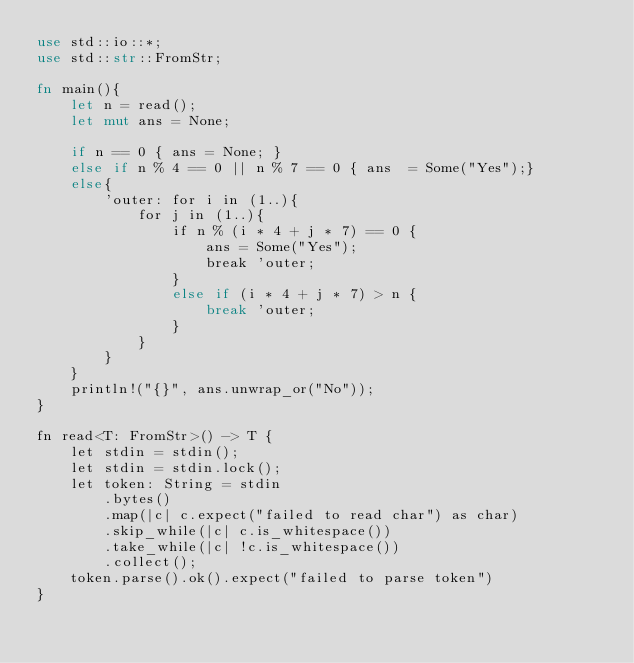Convert code to text. <code><loc_0><loc_0><loc_500><loc_500><_Rust_>use std::io::*;
use std::str::FromStr;

fn main(){
    let n = read();
    let mut ans = None;
     
    if n == 0 { ans = None; }
    else if n % 4 == 0 || n % 7 == 0 { ans  = Some("Yes");}
    else{
        'outer: for i in (1..){
            for j in (1..){
                if n % (i * 4 + j * 7) == 0 {
                    ans = Some("Yes");
                    break 'outer;
                }
                else if (i * 4 + j * 7) > n {
                    break 'outer;
                }
            }
        }
    }
    println!("{}", ans.unwrap_or("No"));
} 

fn read<T: FromStr>() -> T {
    let stdin = stdin();
    let stdin = stdin.lock();
    let token: String = stdin
        .bytes()
        .map(|c| c.expect("failed to read char") as char) 
        .skip_while(|c| c.is_whitespace())
        .take_while(|c| !c.is_whitespace())
        .collect();
    token.parse().ok().expect("failed to parse token")
}</code> 